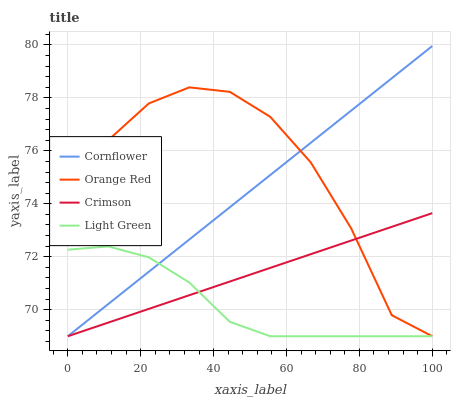Does Light Green have the minimum area under the curve?
Answer yes or no. Yes. Does Orange Red have the maximum area under the curve?
Answer yes or no. Yes. Does Cornflower have the minimum area under the curve?
Answer yes or no. No. Does Cornflower have the maximum area under the curve?
Answer yes or no. No. Is Crimson the smoothest?
Answer yes or no. Yes. Is Orange Red the roughest?
Answer yes or no. Yes. Is Cornflower the smoothest?
Answer yes or no. No. Is Cornflower the roughest?
Answer yes or no. No. Does Crimson have the lowest value?
Answer yes or no. Yes. Does Cornflower have the highest value?
Answer yes or no. Yes. Does Orange Red have the highest value?
Answer yes or no. No. Does Cornflower intersect Orange Red?
Answer yes or no. Yes. Is Cornflower less than Orange Red?
Answer yes or no. No. Is Cornflower greater than Orange Red?
Answer yes or no. No. 